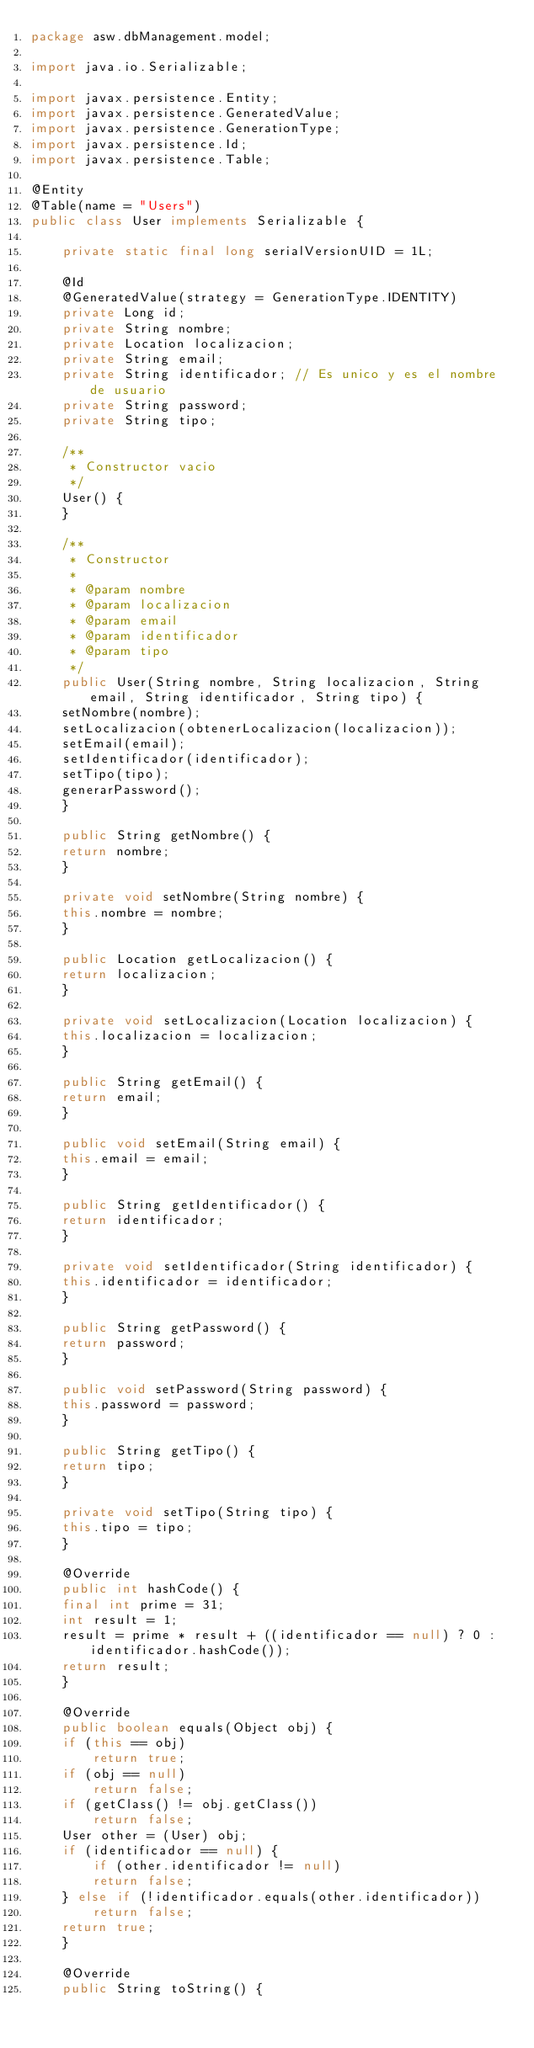<code> <loc_0><loc_0><loc_500><loc_500><_Java_>package asw.dbManagement.model;

import java.io.Serializable;

import javax.persistence.Entity;
import javax.persistence.GeneratedValue;
import javax.persistence.GenerationType;
import javax.persistence.Id;
import javax.persistence.Table;

@Entity
@Table(name = "Users")
public class User implements Serializable {

    private static final long serialVersionUID = 1L;

    @Id
    @GeneratedValue(strategy = GenerationType.IDENTITY)
    private Long id;
    private String nombre;
    private Location localizacion;
    private String email;
    private String identificador; // Es unico y es el nombre de usuario
    private String password;
    private String tipo;

    /**
     * Constructor vacio
     */
    User() {
    }

    /**
     * Constructor
     * 
     * @param nombre
     * @param localizacion
     * @param email
     * @param identificador
     * @param tipo
     */
    public User(String nombre, String localizacion, String email, String identificador, String tipo) {
	setNombre(nombre);
	setLocalizacion(obtenerLocalizacion(localizacion));
	setEmail(email);
	setIdentificador(identificador);
	setTipo(tipo);
	generarPassword();
    }

    public String getNombre() {
	return nombre;
    }

    private void setNombre(String nombre) {
	this.nombre = nombre;
    }

    public Location getLocalizacion() {
	return localizacion;
    }

    private void setLocalizacion(Location localizacion) {
	this.localizacion = localizacion;
    }

    public String getEmail() {
	return email;
    }

    public void setEmail(String email) {
	this.email = email;
    }

    public String getIdentificador() {
	return identificador;
    }

    private void setIdentificador(String identificador) {
	this.identificador = identificador;
    }

    public String getPassword() {
	return password;
    }

    public void setPassword(String password) {
	this.password = password;
    }

    public String getTipo() {
	return tipo;
    }

    private void setTipo(String tipo) {
	this.tipo = tipo;
    }

    @Override
    public int hashCode() {
	final int prime = 31;
	int result = 1;
	result = prime * result + ((identificador == null) ? 0 : identificador.hashCode());
	return result;
    }

    @Override
    public boolean equals(Object obj) {
	if (this == obj)
	    return true;
	if (obj == null)
	    return false;
	if (getClass() != obj.getClass())
	    return false;
	User other = (User) obj;
	if (identificador == null) {
	    if (other.identificador != null)
		return false;
	} else if (!identificador.equals(other.identificador))
	    return false;
	return true;
    }

    @Override
    public String toString() {</code> 